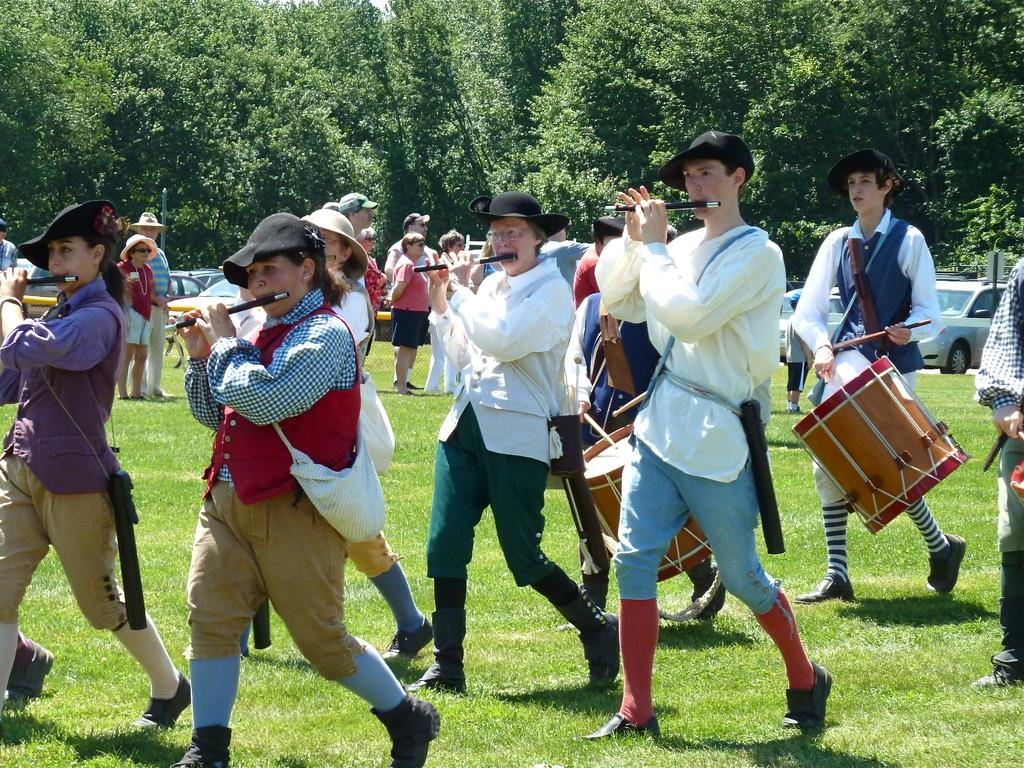What are the people in the image doing? The people in the image are playing musical instruments. What can be seen in the background of the image? There are trees and vehicles in the background of the image. What type of turkey can be seen in the image? There is no turkey present in the image. Can you tell me who the father of the person playing the instrument is? The image does not provide any information about the relationships between the people in the image, so we cannot determine who the father of the person playing the instrument is. 